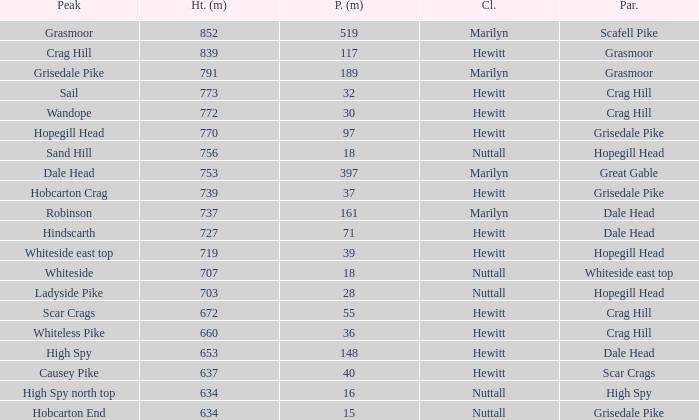Which Class is Peak Sail when it has a Prom larger than 30? Hewitt. 